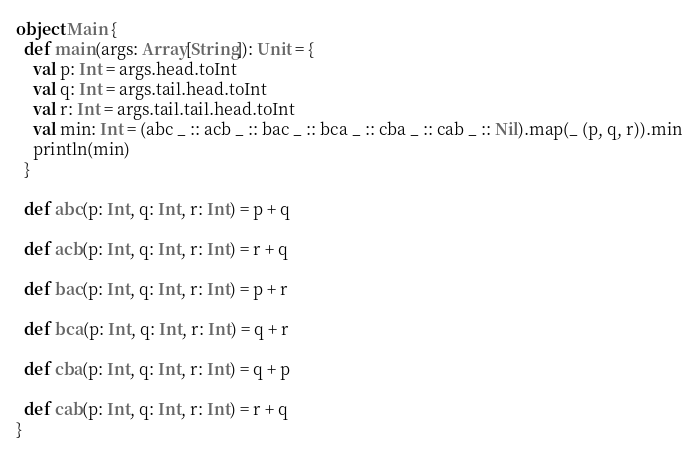Convert code to text. <code><loc_0><loc_0><loc_500><loc_500><_Scala_>object Main {
  def main(args: Array[String]): Unit = {
    val p: Int = args.head.toInt
    val q: Int = args.tail.head.toInt
    val r: Int = args.tail.tail.head.toInt
    val min: Int = (abc _ :: acb _ :: bac _ :: bca _ :: cba _ :: cab _ :: Nil).map(_ (p, q, r)).min
    println(min)
  }

  def abc(p: Int, q: Int, r: Int) = p + q

  def acb(p: Int, q: Int, r: Int) = r + q

  def bac(p: Int, q: Int, r: Int) = p + r

  def bca(p: Int, q: Int, r: Int) = q + r

  def cba(p: Int, q: Int, r: Int) = q + p

  def cab(p: Int, q: Int, r: Int) = r + q
}
</code> 